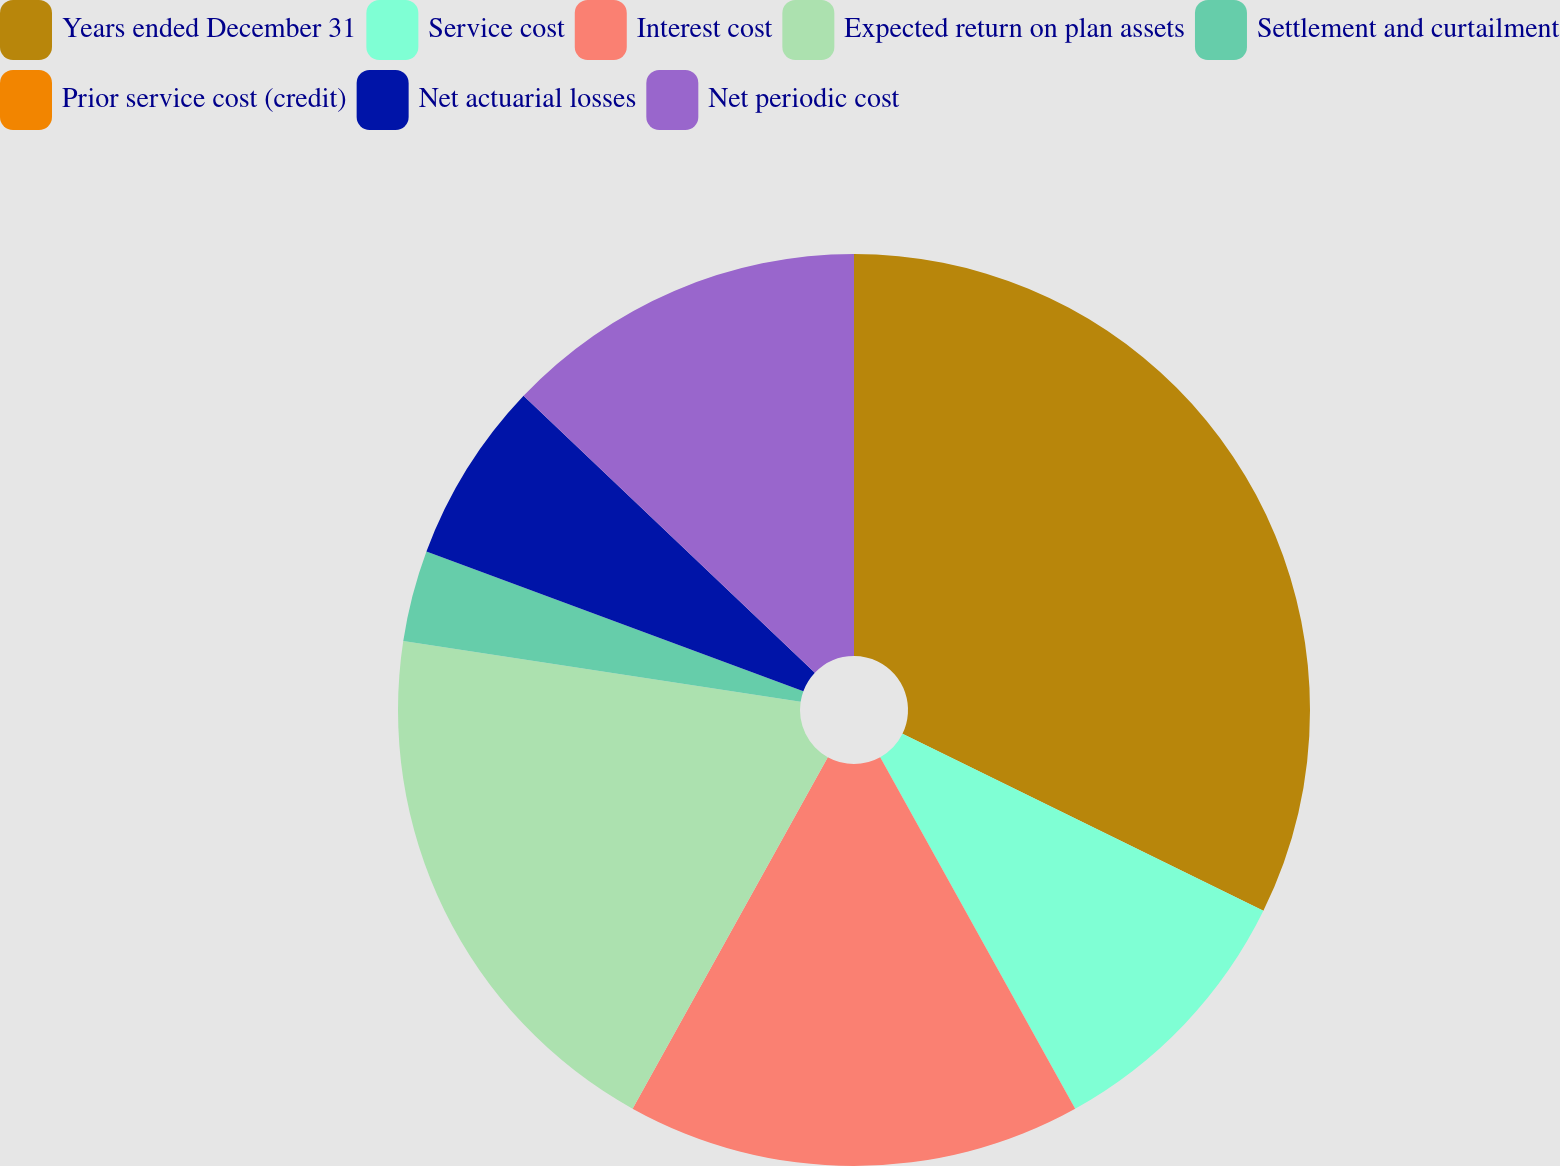Convert chart. <chart><loc_0><loc_0><loc_500><loc_500><pie_chart><fcel>Years ended December 31<fcel>Service cost<fcel>Interest cost<fcel>Expected return on plan assets<fcel>Settlement and curtailment<fcel>Prior service cost (credit)<fcel>Net actuarial losses<fcel>Net periodic cost<nl><fcel>32.26%<fcel>9.68%<fcel>16.13%<fcel>19.35%<fcel>3.23%<fcel>0.0%<fcel>6.45%<fcel>12.9%<nl></chart> 